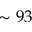Convert formula to latex. <formula><loc_0><loc_0><loc_500><loc_500>\sim 9 3</formula> 